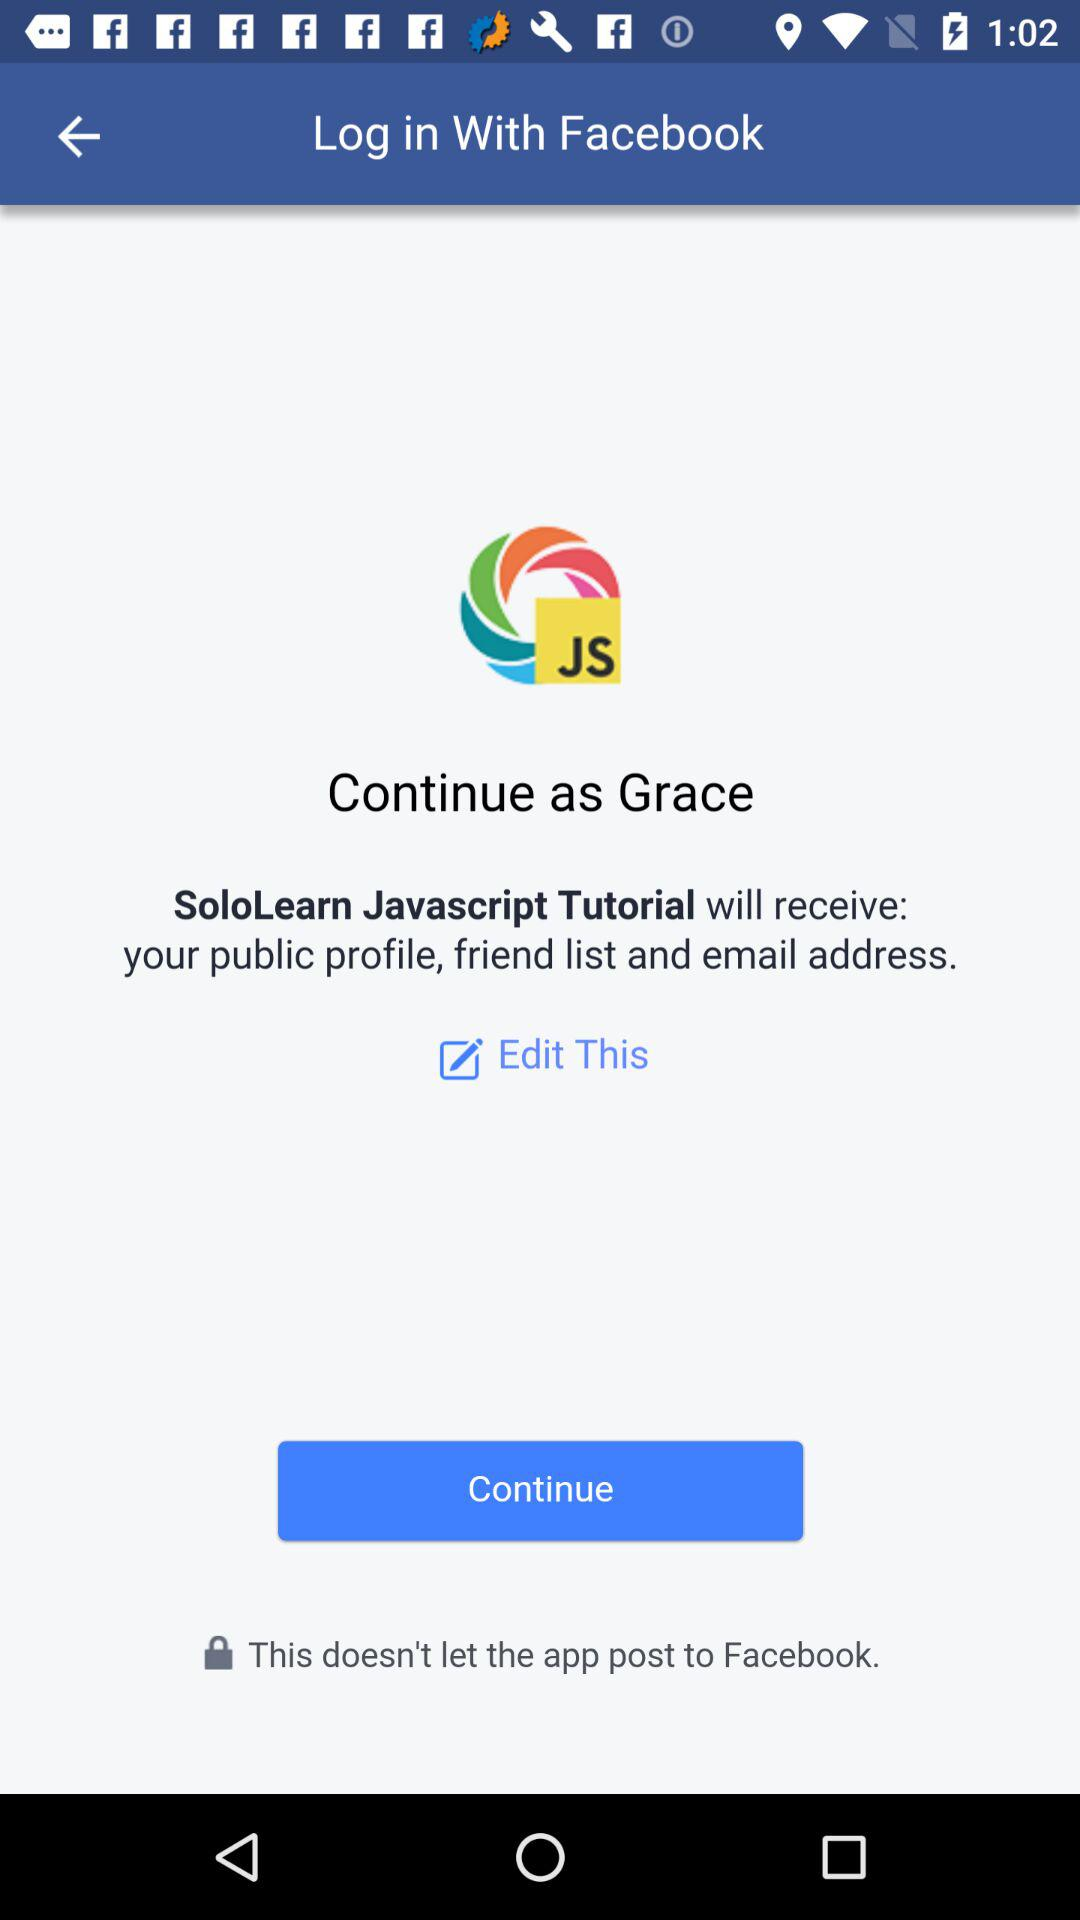What is the name of the user? The name of the user is Grace. 